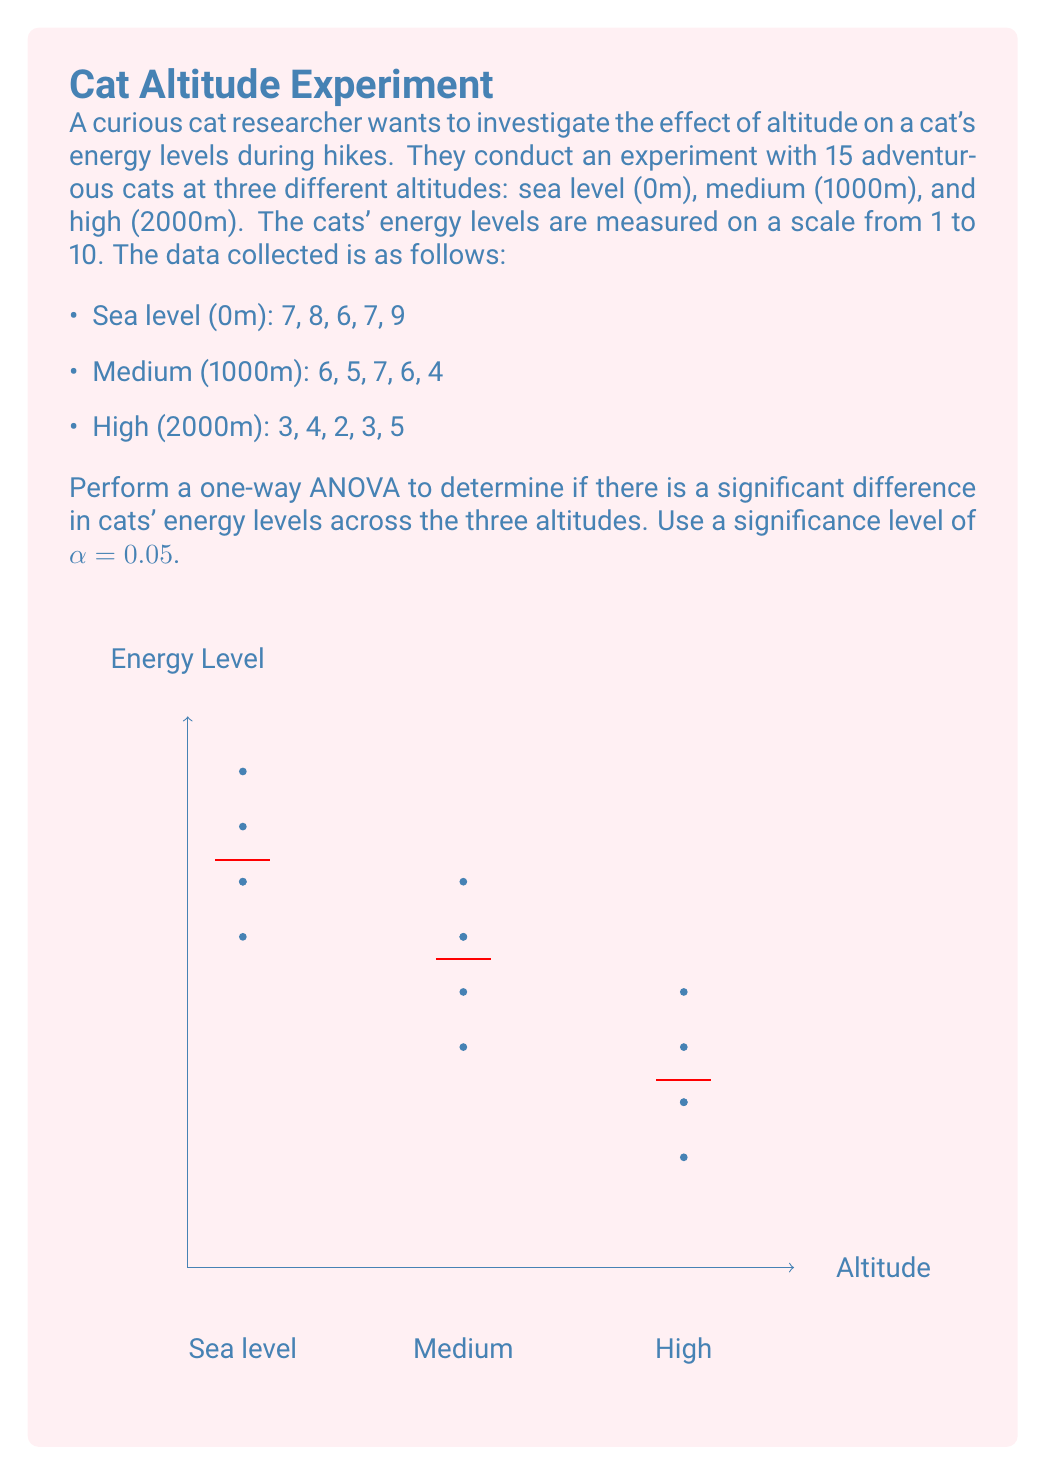Give your solution to this math problem. To perform a one-way ANOVA, we'll follow these steps:

1. Calculate the mean for each group:
   Sea level: $\bar{x}_1 = \frac{7+8+6+7+9}{5} = 7.4$
   Medium: $\bar{x}_2 = \frac{6+5+7+6+4}{5} = 5.6$
   High: $\bar{x}_3 = \frac{3+4+2+3+5}{5} = 3.4$

2. Calculate the grand mean:
   $\bar{x} = \frac{7.4 + 5.6 + 3.4}{3} = 5.467$

3. Calculate the Sum of Squares Between (SSB):
   $$SSB = \sum_{i=1}^k n_i(\bar{x}_i - \bar{x})^2$$
   $$SSB = 5(7.4 - 5.467)^2 + 5(5.6 - 5.467)^2 + 5(3.4 - 5.467)^2 = 48.13$$

4. Calculate the Sum of Squares Within (SSW):
   $$SSW = \sum_{i=1}^k \sum_{j=1}^{n_i} (x_{ij} - \bar{x}_i)^2$$
   $$SSW = [(7-7.4)^2 + (8-7.4)^2 + (6-7.4)^2 + (7-7.4)^2 + (9-7.4)^2] +$$
   $$[(6-5.6)^2 + (5-5.6)^2 + (7-5.6)^2 + (6-5.6)^2 + (4-5.6)^2] +$$
   $$[(3-3.4)^2 + (4-3.4)^2 + (2-3.4)^2 + (3-3.4)^2 + (5-3.4)^2]$$
   $$SSW = 7.2 + 6.8 + 6.8 = 20.8$$

5. Calculate the degrees of freedom:
   $df_{between} = k - 1 = 3 - 1 = 2$
   $df_{within} = N - k = 15 - 3 = 12$

6. Calculate the Mean Square Between (MSB) and Mean Square Within (MSW):
   $$MSB = \frac{SSB}{df_{between}} = \frac{48.13}{2} = 24.065$$
   $$MSW = \frac{SSW}{df_{within}} = \frac{20.8}{12} = 1.733$$

7. Calculate the F-statistic:
   $$F = \frac{MSB}{MSW} = \frac{24.065}{1.733} = 13.885$$

8. Find the critical F-value:
   For $α = 0.05$, $df_{between} = 2$, and $df_{within} = 12$, the critical F-value is approximately 3.89.

9. Compare the F-statistic to the critical F-value:
   Since $13.885 > 3.89$, we reject the null hypothesis.
Answer: $F(2,12) = 13.885, p < 0.05$. Significant difference in cats' energy levels across altitudes. 